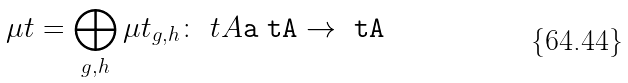Convert formula to latex. <formula><loc_0><loc_0><loc_500><loc_500>\mu t = \bigoplus _ { g , h } \mu t _ { g , h } \colon \ t A \tt a \ t A \to \ t A</formula> 